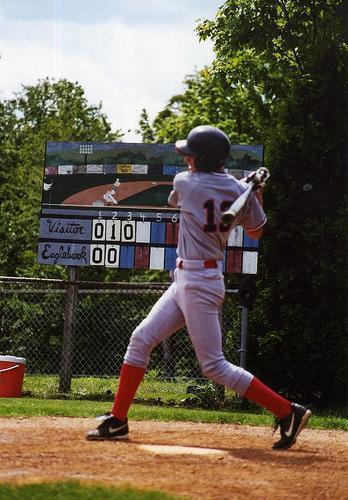How many people are in the picture?
Give a very brief answer. 1. 